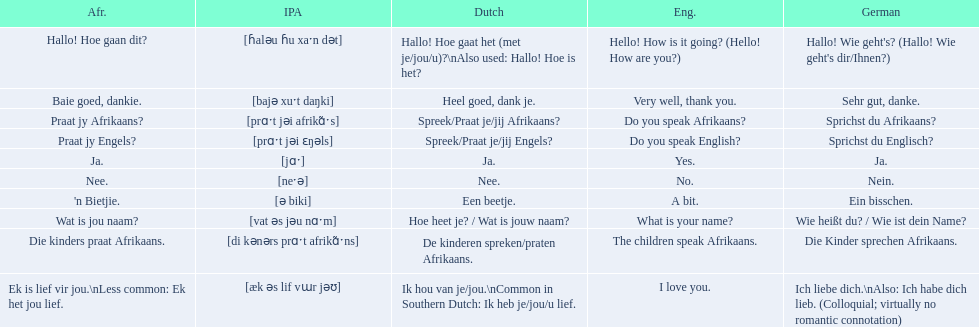How do you say hello! how is it going? in afrikaans? Hallo! Hoe gaan dit?. How do you say very well, thank you in afrikaans? Baie goed, dankie. How would you say do you speak afrikaans? in afrikaans? Praat jy Afrikaans?. 